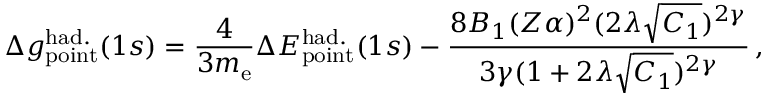Convert formula to latex. <formula><loc_0><loc_0><loc_500><loc_500>\Delta { g } _ { p o i n t } ^ { h a d . } ( 1 s ) = \frac { 4 } { 3 m _ { e } } \Delta { E } _ { p o i n t } ^ { h a d . } ( 1 s ) - \frac { 8 B _ { 1 } ( Z \alpha ) ^ { 2 } ( 2 \lambda \sqrt { C _ { 1 } } ) ^ { 2 \gamma } } { 3 \gamma ( 1 + 2 \lambda \sqrt { C _ { 1 } } ) ^ { 2 \gamma } } \, ,</formula> 